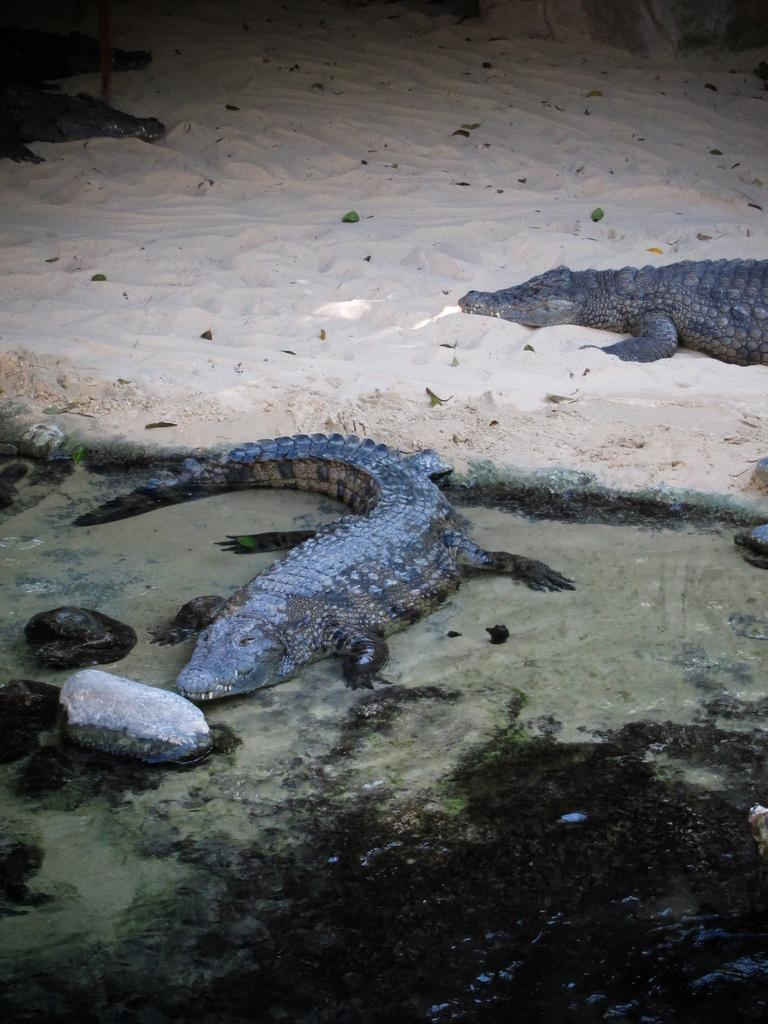How many crocodiles are in the image? There are two crocodiles in the image. What colors are the crocodiles? The crocodiles are in brown and gray colors. What else can be seen in the image besides the crocodiles? There are stones visible in the image. What is the color of the sand in the background of the image? The background of the image consists of sand in a cream color. What type of bell is being rung by the servant in the image? There is no servant or bell present in the image; it features two crocodiles and stones in a sandy background. 